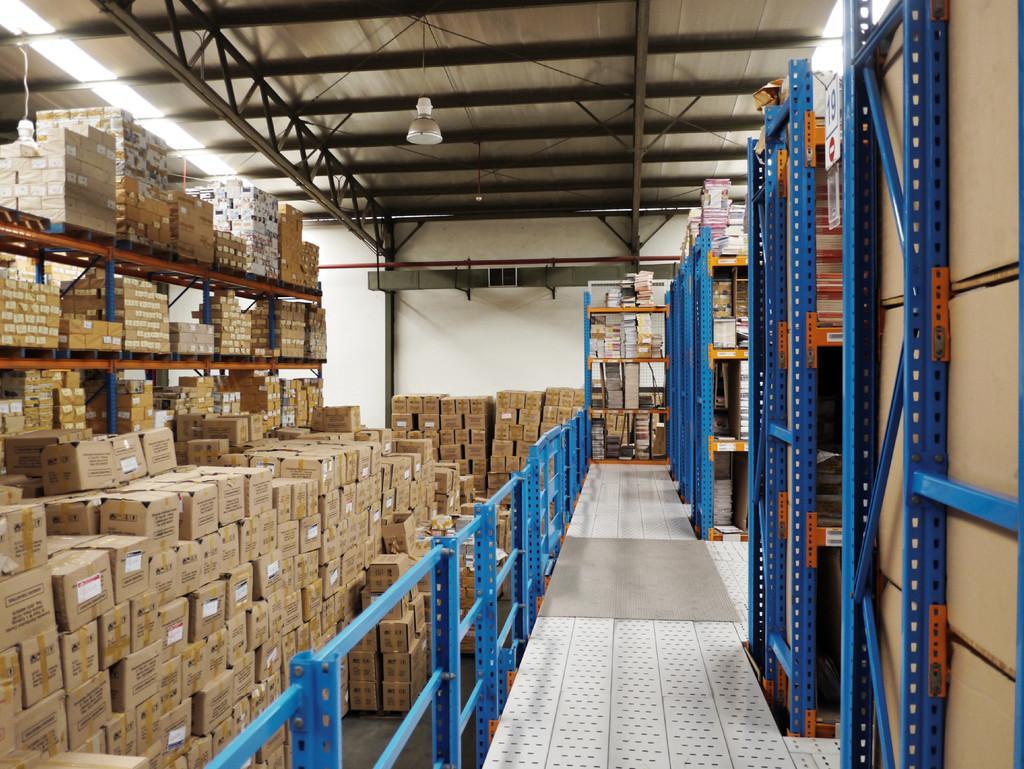In one or two sentences, can you explain what this image depicts? In this image, we can some boxes. There are cracks on the right side of the image. There is a light in the top left and at the top of the image. 